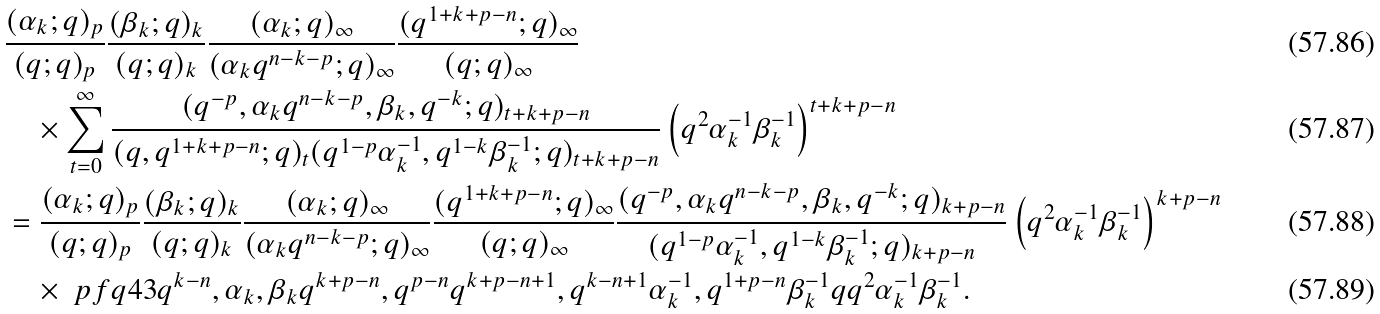<formula> <loc_0><loc_0><loc_500><loc_500>& \frac { ( \alpha _ { k } ; q ) _ { p } } { ( q ; q ) _ { p } } \frac { ( \beta _ { k } ; q ) _ { k } } { ( q ; q ) _ { k } } \frac { ( \alpha _ { k } ; q ) _ { \infty } } { ( \alpha _ { k } q ^ { n - k - p } ; q ) _ { \infty } } \frac { ( q ^ { 1 + k + p - n } ; q ) _ { \infty } } { ( q ; q ) _ { \infty } } \\ & \quad \times \sum _ { t = 0 } ^ { \infty } \frac { ( q ^ { - p } , \alpha _ { k } q ^ { n - k - p } , \beta _ { k } , q ^ { - k } ; q ) _ { t + k + p - n } } { ( q , q ^ { 1 + k + p - n } ; q ) _ { t } ( q ^ { 1 - p } \alpha _ { k } ^ { - 1 } , q ^ { 1 - k } \beta _ { k } ^ { - 1 } ; q ) _ { t + k + p - n } } \left ( q ^ { 2 } \alpha _ { k } ^ { - 1 } \beta _ { k } ^ { - 1 } \right ) ^ { t + k + p - n } \\ & = \frac { ( \alpha _ { k } ; q ) _ { p } } { ( q ; q ) _ { p } } \frac { ( \beta _ { k } ; q ) _ { k } } { ( q ; q ) _ { k } } \frac { ( \alpha _ { k } ; q ) _ { \infty } } { ( \alpha _ { k } q ^ { n - k - p } ; q ) _ { \infty } } \frac { ( q ^ { 1 + k + p - n } ; q ) _ { \infty } } { ( q ; q ) _ { \infty } } \frac { ( q ^ { - p } , \alpha _ { k } q ^ { n - k - p } , \beta _ { k } , q ^ { - k } ; q ) _ { k + p - n } } { ( q ^ { 1 - p } \alpha _ { k } ^ { - 1 } , q ^ { 1 - k } \beta _ { k } ^ { - 1 } ; q ) _ { k + p - n } } \left ( q ^ { 2 } \alpha _ { k } ^ { - 1 } \beta _ { k } ^ { - 1 } \right ) ^ { k + p - n } \\ & \quad \times \ p f q { 4 } { 3 } { q ^ { k - n } , \alpha _ { k } , \beta _ { k } q ^ { k + p - n } , q ^ { p - n } } { q ^ { k + p - n + 1 } , q ^ { k - n + 1 } \alpha _ { k } ^ { - 1 } , q ^ { 1 + p - n } \beta _ { k } ^ { - 1 } } { q } { q ^ { 2 } \alpha _ { k } ^ { - 1 } \beta _ { k } ^ { - 1 } } .</formula> 